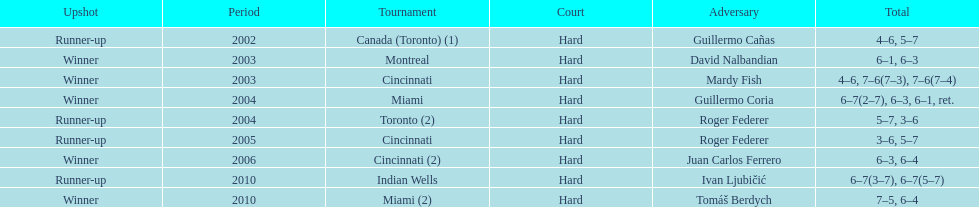In miami, how many instances of the championship have occurred? 2. 